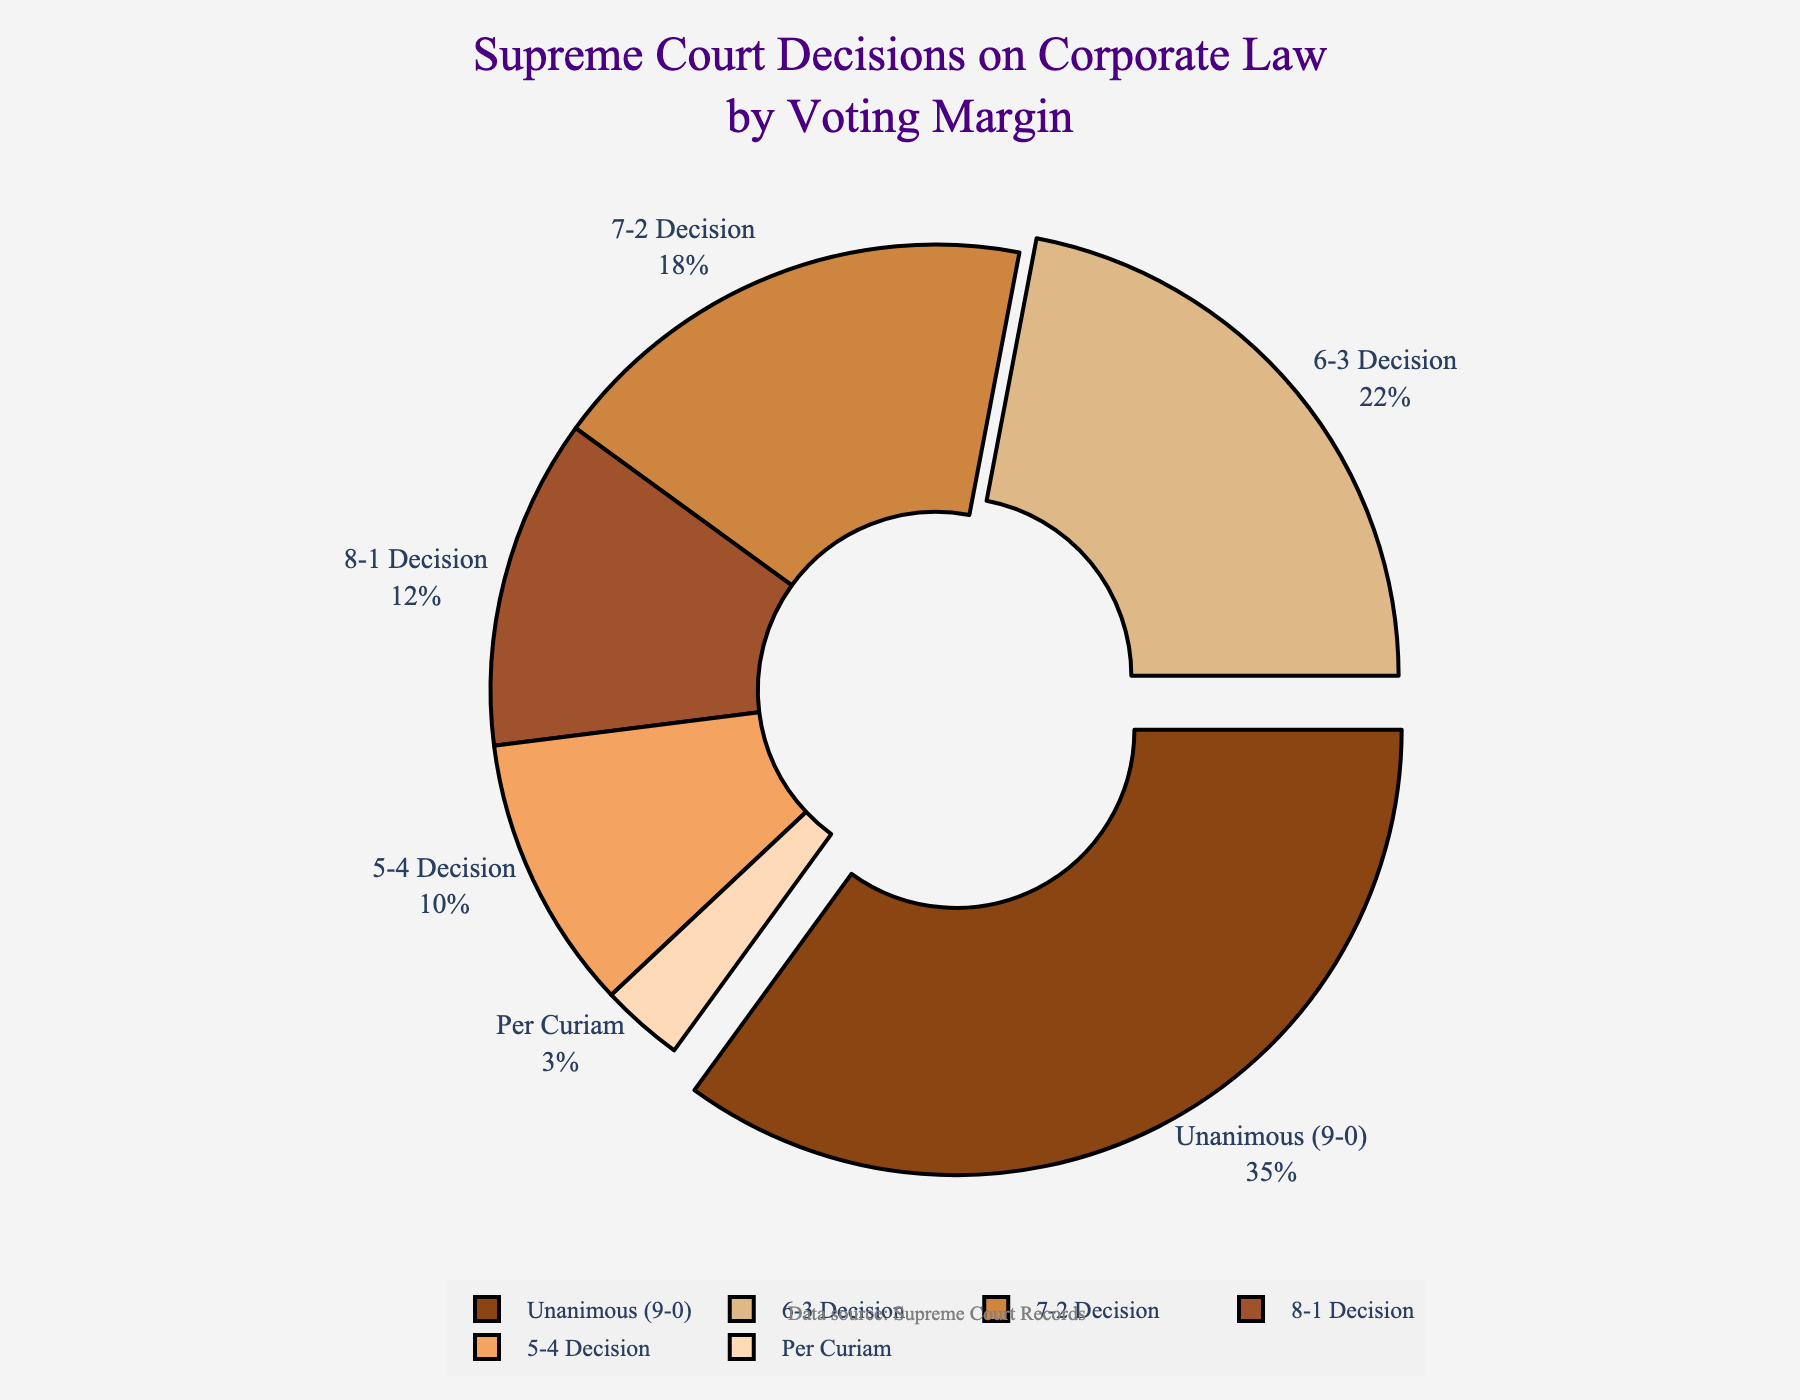What percentage of Supreme Court decisions on corporate law were unanimous (9-0)? By looking at the chart, we can see that the slice labeled "Unanimous (9-0)" occupies 35% of the pie.
Answer: 35% What is the difference in percentage between 7-2 decisions and 5-4 decisions? The percentage for 7-2 decisions is 18%, and for 5-4 decisions, it is 10%. Subtracting these, we get 18% - 10% = 8%.
Answer: 8% Which voting margin category has the smallest percentage of decisions? The smallest slice in the pie chart is labeled "Per Curiam," which occupies 3% of the pie.
Answer: Per Curiam How much larger is the percentage of unanimous (9-0) decisions compared to 8-1 decisions? The percentage for unanimous (9-0) decisions is 35%, and for 8-1 decisions, it is 12%. Subtracting these, we get 35% - 12% = 23%.
Answer: 23% What is the combined percentage of 6-3 and 5-4 decisions? The percentage for 6-3 decisions is 22% and for 5-4 decisions is 10%. Adding these, we get 22% + 10% = 32%.
Answer: 32% If we exclude unanimous (9-0) and Per Curiam decisions, what percentage does the remaining categories account for? Excluding "Unanimous (9-0)" at 35% and "Per Curiam" at 3%, we sum the percentages of the remaining categories: 12% (8-1) + 18% (7-2) + 22% (6-3) + 10% (5-4) = 62%.
Answer: 62% Which category is visually pulled out slightly from the pie chart? From the visual cues, the slices labeled "Unanimous (9-0)" and "6-3 Decision" are slightly pulled out from the pie chart.
Answer: Unanimous (9-0) and 6-3 Decision What is the average percentage of all categories? The percentages are 35%, 12%, 18%, 22%, 10%, and 3%. Summing these, we get 100%. Dividing by 6 categories, we get 100% / 6 ≈ 16.67%.
Answer: 16.67% Which voting margin categories have a percentage greater than 20%? From the chart, the categories with percentages greater than 20% are "Unanimous (9-0)" at 35% and "6-3 Decision" at 22%.
Answer: Unanimous (9-0) and 6-3 Decision 